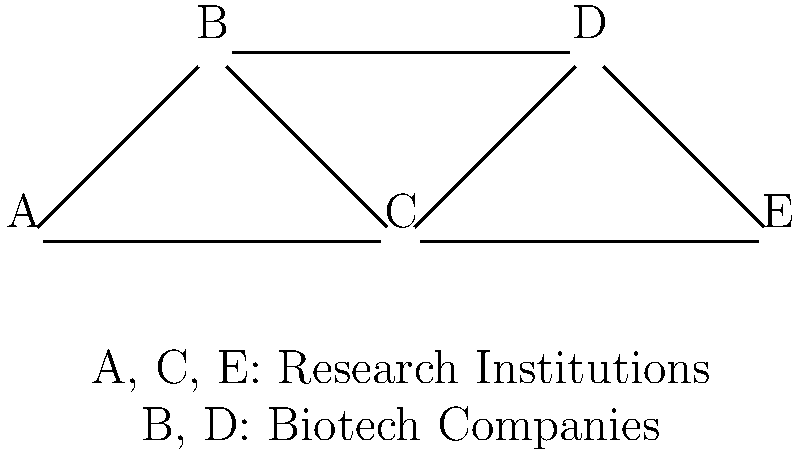Given the network diagram representing collaborations between research institutions (A, C, E) and biotech companies (B, D), what is the betweenness centrality of node C? Assume that each edge has a weight of 1 and consider only the shortest paths between all pairs of nodes. To calculate the betweenness centrality of node C, we need to follow these steps:

1. Identify all pairs of nodes excluding C:
   (A,B), (A,D), (A,E), (B,D), (B,E), (D,E)

2. Count the number of shortest paths between each pair:
   (A,B): 1 path (A-B)
   (A,D): 2 paths (A-B-D and A-C-D)
   (A,E): 1 path (A-C-E)
   (B,D): 1 path (B-D)
   (B,E): 2 paths (B-C-E and B-D-E)
   (D,E): 1 path (D-E)

3. Count how many of these shortest paths pass through C:
   (A,B): 0
   (A,D): 1 (A-C-D)
   (A,E): 1 (A-C-E)
   (B,D): 0
   (B,E): 1 (B-C-E)
   (D,E): 0

4. Calculate the fraction of shortest paths that pass through C for each pair:
   (A,B): 0/1 = 0
   (A,D): 1/2 = 0.5
   (A,E): 1/1 = 1
   (B,D): 0/1 = 0
   (B,E): 1/2 = 0.5
   (D,E): 0/1 = 0

5. Sum up all these fractions:
   Betweenness centrality of C = 0 + 0.5 + 1 + 0 + 0.5 + 0 = 2

Therefore, the betweenness centrality of node C is 2.
Answer: 2 